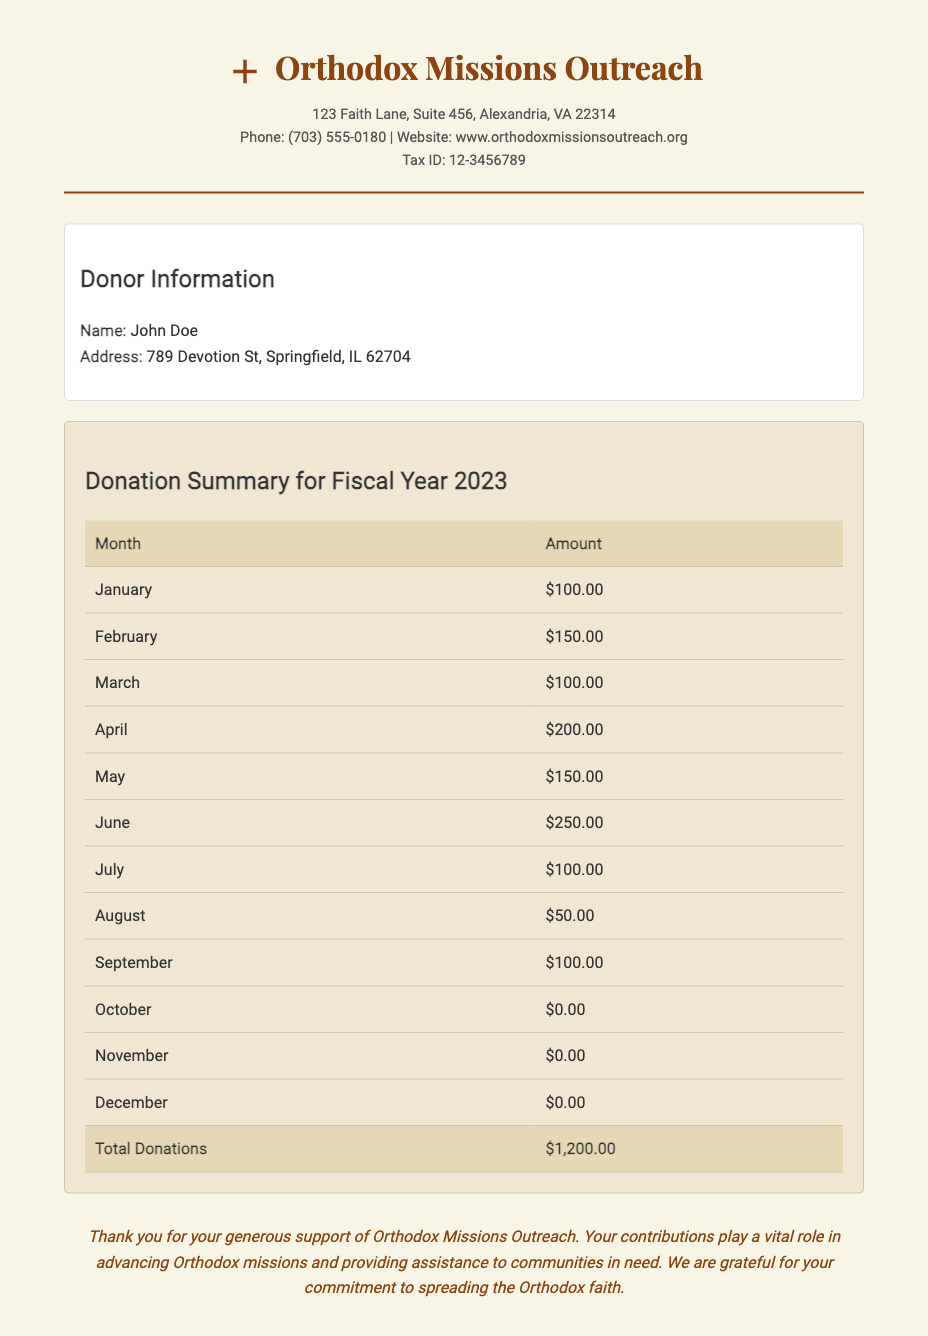what is the name of the charity organization? The name of the charity organization is clearly stated in the document's header section as Orthodox Missions Outreach.
Answer: Orthodox Missions Outreach what is the total amount of donations? The total amount donated over the fiscal year is summarized in the donation summary section as $1,200.00.
Answer: $1,200.00 how many months did John Doe contribute in 2023? To determine how many months John Doe contributed, we count the months with non-zero amounts: January to July and September. This gives us a total of 8 months.
Answer: 8 months what is the donor's address? The donor's address is provided in the donor info section as 789 Devotion St, Springfield, IL 62704.
Answer: 789 Devotion St, Springfield, IL 62704 which month had the highest contribution? The month with the highest contribution is June, which is listed with a donation amount of $250.00.
Answer: June what is the tax ID for Orthodox Missions Outreach? The tax ID for the organization is listed in the org info section as 12-3456789.
Answer: 12-3456789 how much did John Doe donate in August? The donation amount for August is specifically mentioned in the donation summary as $50.00.
Answer: $50.00 what message does the document convey at the end? The message at the end expresses gratitude for the contributions and highlights their importance in supporting Orthodox missions.
Answer: Thank you for your generous support.. what is the phone number listed for the organization? The phone number for Orthodox Missions Outreach is provided in the org info section as (703) 555-0180.
Answer: (703) 555-0180 